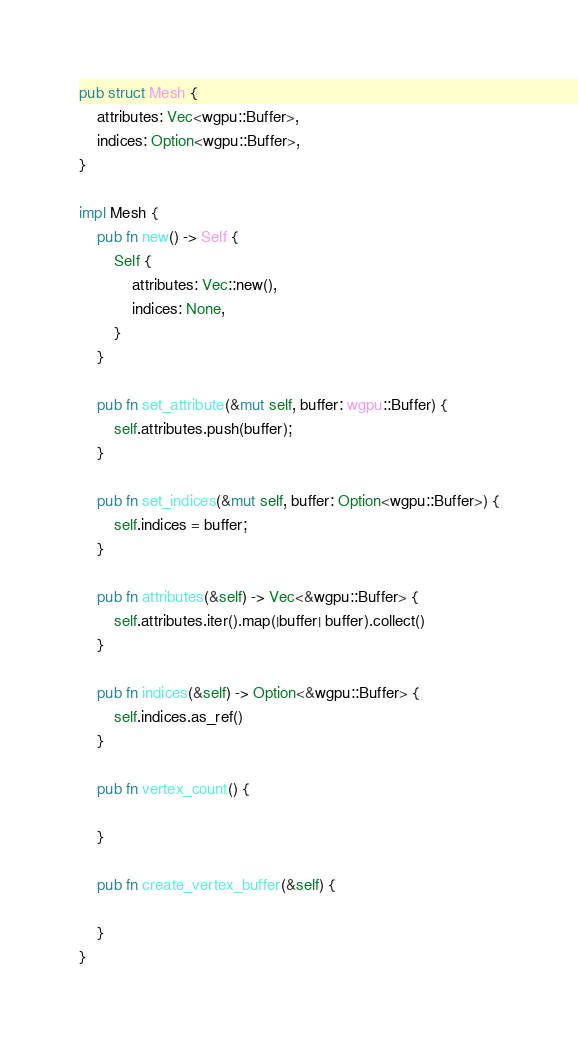Convert code to text. <code><loc_0><loc_0><loc_500><loc_500><_Rust_>pub struct Mesh {
    attributes: Vec<wgpu::Buffer>,
    indices: Option<wgpu::Buffer>,
}

impl Mesh {
    pub fn new() -> Self {
        Self {
            attributes: Vec::new(),
            indices: None,
        }
    }

    pub fn set_attribute(&mut self, buffer: wgpu::Buffer) {
        self.attributes.push(buffer);
    }

    pub fn set_indices(&mut self, buffer: Option<wgpu::Buffer>) {
        self.indices = buffer;
    }

    pub fn attributes(&self) -> Vec<&wgpu::Buffer> {
        self.attributes.iter().map(|buffer| buffer).collect()
    }

    pub fn indices(&self) -> Option<&wgpu::Buffer> {
        self.indices.as_ref()
    }

    pub fn vertex_count() {

    }

    pub fn create_vertex_buffer(&self) {

    }
}
</code> 